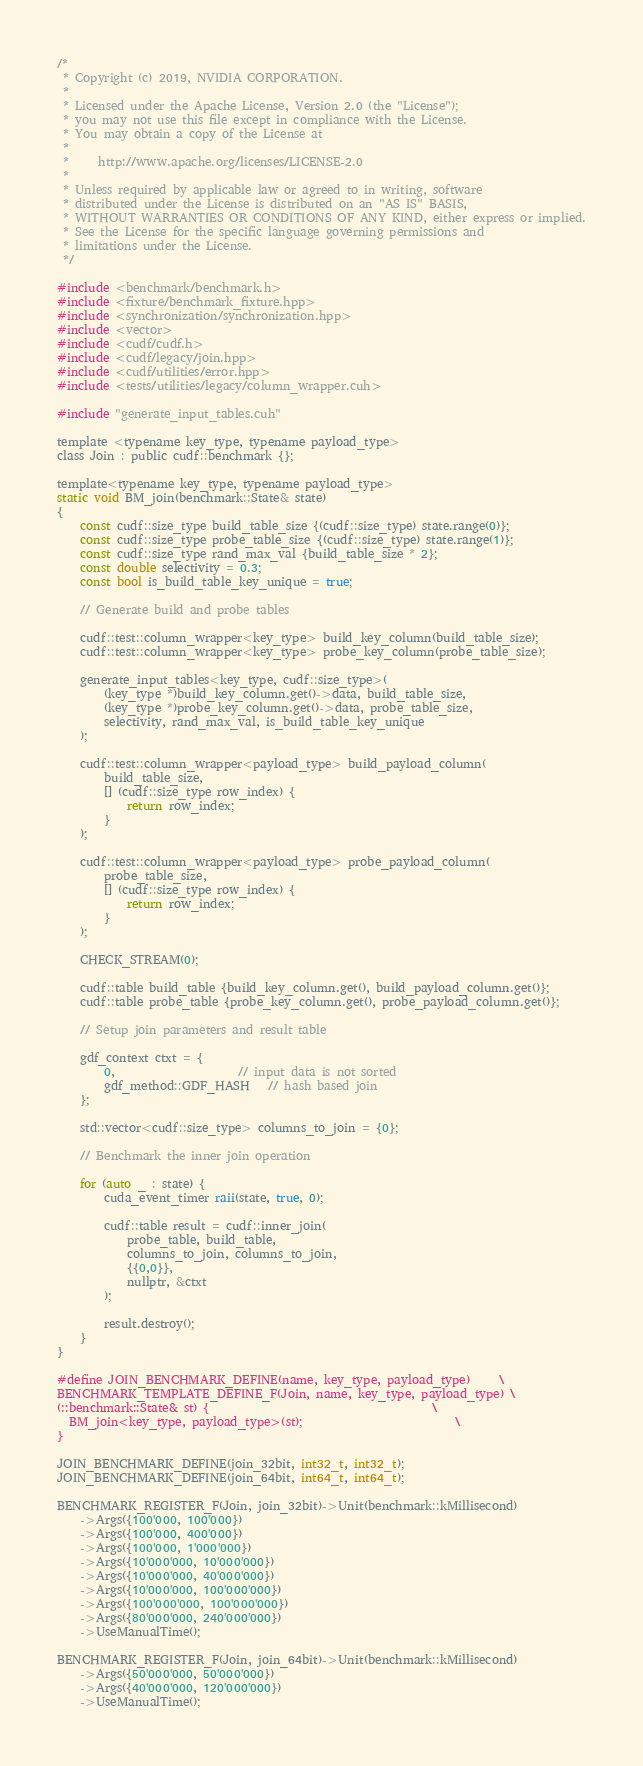Convert code to text. <code><loc_0><loc_0><loc_500><loc_500><_Cuda_>/*
 * Copyright (c) 2019, NVIDIA CORPORATION.
 *
 * Licensed under the Apache License, Version 2.0 (the "License");
 * you may not use this file except in compliance with the License.
 * You may obtain a copy of the License at
 *
 *     http://www.apache.org/licenses/LICENSE-2.0
 *
 * Unless required by applicable law or agreed to in writing, software
 * distributed under the License is distributed on an "AS IS" BASIS,
 * WITHOUT WARRANTIES OR CONDITIONS OF ANY KIND, either express or implied.
 * See the License for the specific language governing permissions and
 * limitations under the License.
 */

#include <benchmark/benchmark.h>
#include <fixture/benchmark_fixture.hpp>
#include <synchronization/synchronization.hpp>
#include <vector>
#include <cudf/cudf.h>
#include <cudf/legacy/join.hpp>
#include <cudf/utilities/error.hpp>
#include <tests/utilities/legacy/column_wrapper.cuh>

#include "generate_input_tables.cuh"

template <typename key_type, typename payload_type>
class Join : public cudf::benchmark {};

template<typename key_type, typename payload_type>
static void BM_join(benchmark::State& state)
{
    const cudf::size_type build_table_size {(cudf::size_type) state.range(0)};
    const cudf::size_type probe_table_size {(cudf::size_type) state.range(1)};
    const cudf::size_type rand_max_val {build_table_size * 2};
    const double selectivity = 0.3;
    const bool is_build_table_key_unique = true;

    // Generate build and probe tables

    cudf::test::column_wrapper<key_type> build_key_column(build_table_size);
    cudf::test::column_wrapper<key_type> probe_key_column(probe_table_size);

    generate_input_tables<key_type, cudf::size_type>(
        (key_type *)build_key_column.get()->data, build_table_size,
        (key_type *)probe_key_column.get()->data, probe_table_size,
        selectivity, rand_max_val, is_build_table_key_unique
    );

    cudf::test::column_wrapper<payload_type> build_payload_column(
        build_table_size,
        [] (cudf::size_type row_index) {
            return row_index;
        }
    );

    cudf::test::column_wrapper<payload_type> probe_payload_column(
        probe_table_size,
        [] (cudf::size_type row_index) {
            return row_index;
        }
    );

    CHECK_STREAM(0);

    cudf::table build_table {build_key_column.get(), build_payload_column.get()};
    cudf::table probe_table {probe_key_column.get(), probe_payload_column.get()};

    // Setup join parameters and result table

    gdf_context ctxt = {
        0,                     // input data is not sorted
        gdf_method::GDF_HASH   // hash based join
    };

    std::vector<cudf::size_type> columns_to_join = {0};

    // Benchmark the inner join operation

    for (auto _ : state) {
        cuda_event_timer raii(state, true, 0);

        cudf::table result = cudf::inner_join(
            probe_table, build_table, 
            columns_to_join, columns_to_join,
            {{0,0}},
            nullptr, &ctxt
        );

        result.destroy();
    }
}

#define JOIN_BENCHMARK_DEFINE(name, key_type, payload_type)     \
BENCHMARK_TEMPLATE_DEFINE_F(Join, name, key_type, payload_type) \
(::benchmark::State& st) {                                      \
  BM_join<key_type, payload_type>(st);                          \
}

JOIN_BENCHMARK_DEFINE(join_32bit, int32_t, int32_t);
JOIN_BENCHMARK_DEFINE(join_64bit, int64_t, int64_t);

BENCHMARK_REGISTER_F(Join, join_32bit)->Unit(benchmark::kMillisecond)
    ->Args({100'000, 100'000})
    ->Args({100'000, 400'000})
    ->Args({100'000, 1'000'000})
    ->Args({10'000'000, 10'000'000})
    ->Args({10'000'000, 40'000'000})
    ->Args({10'000'000, 100'000'000})
    ->Args({100'000'000, 100'000'000})
    ->Args({80'000'000, 240'000'000})
    ->UseManualTime();

BENCHMARK_REGISTER_F(Join, join_64bit)->Unit(benchmark::kMillisecond)
    ->Args({50'000'000, 50'000'000})
    ->Args({40'000'000, 120'000'000})
    ->UseManualTime();
</code> 